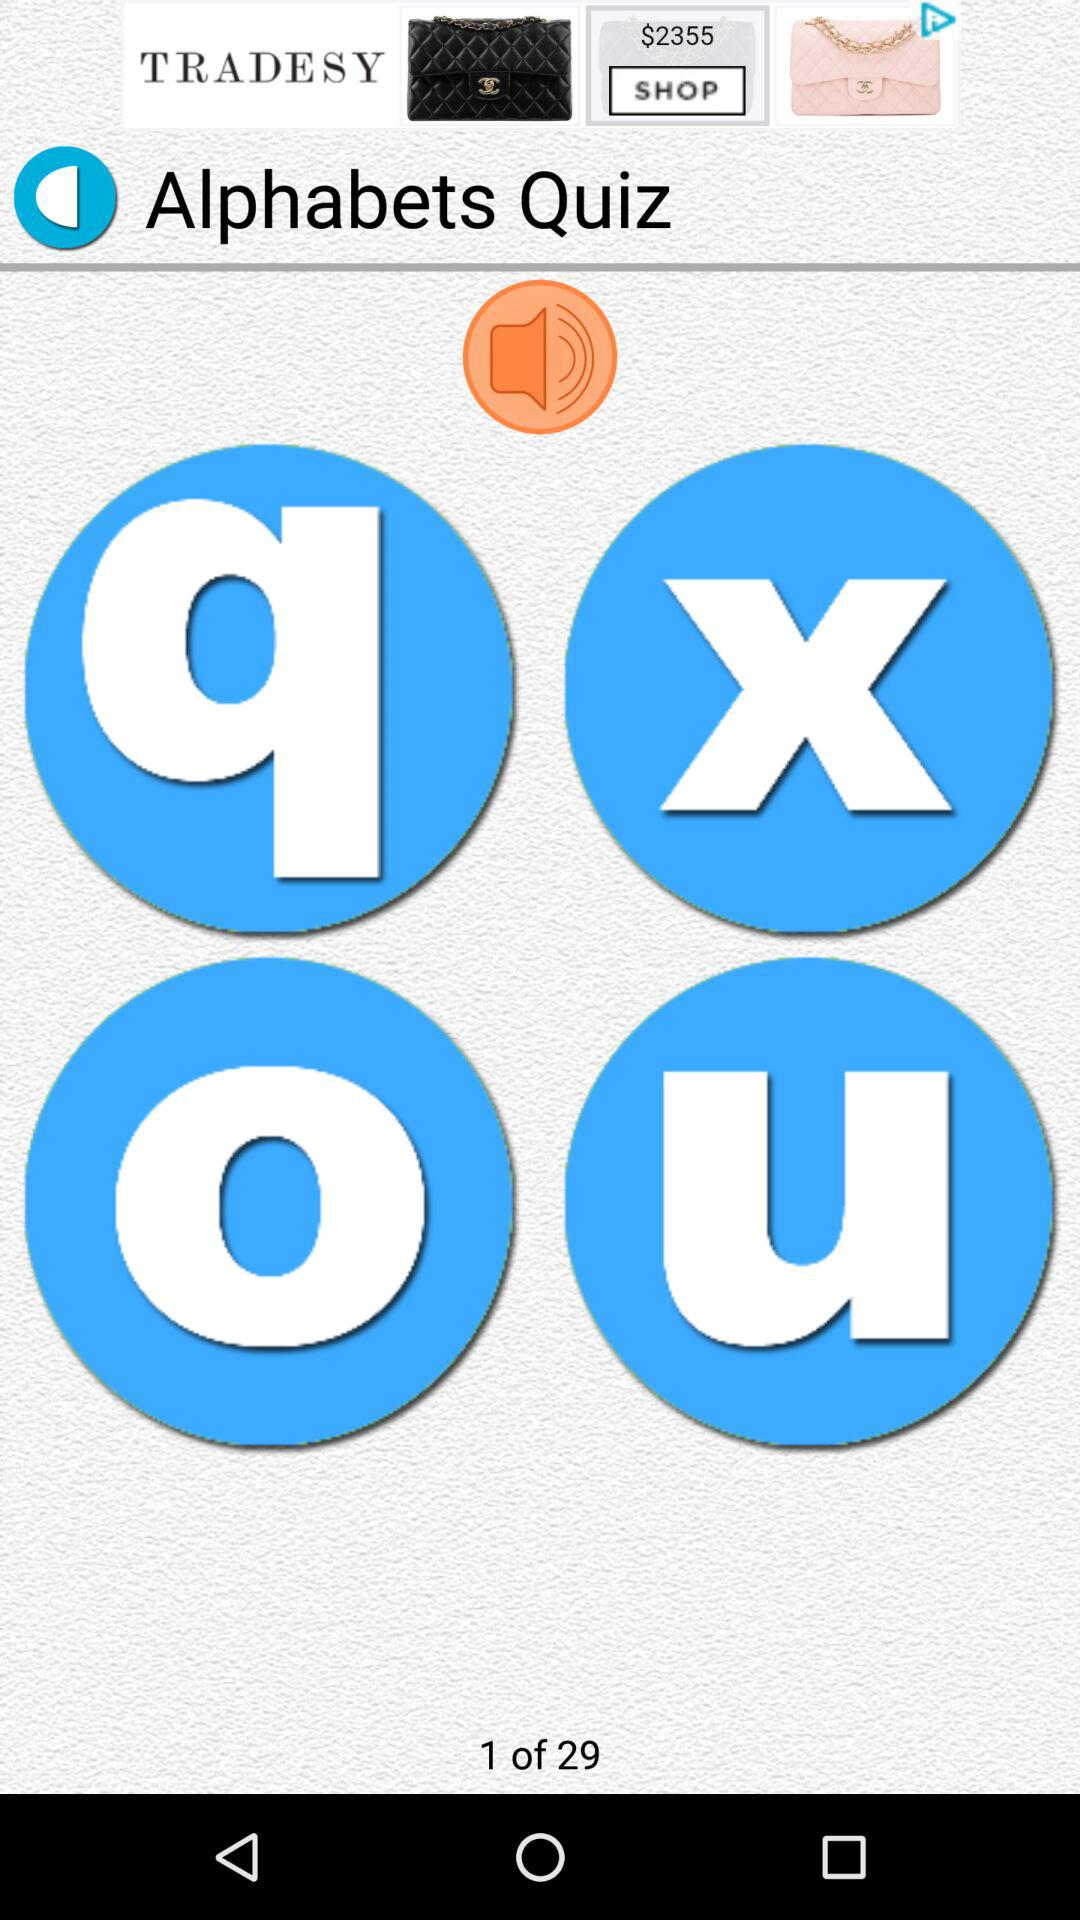How many questions are there? There are 29 questions. 